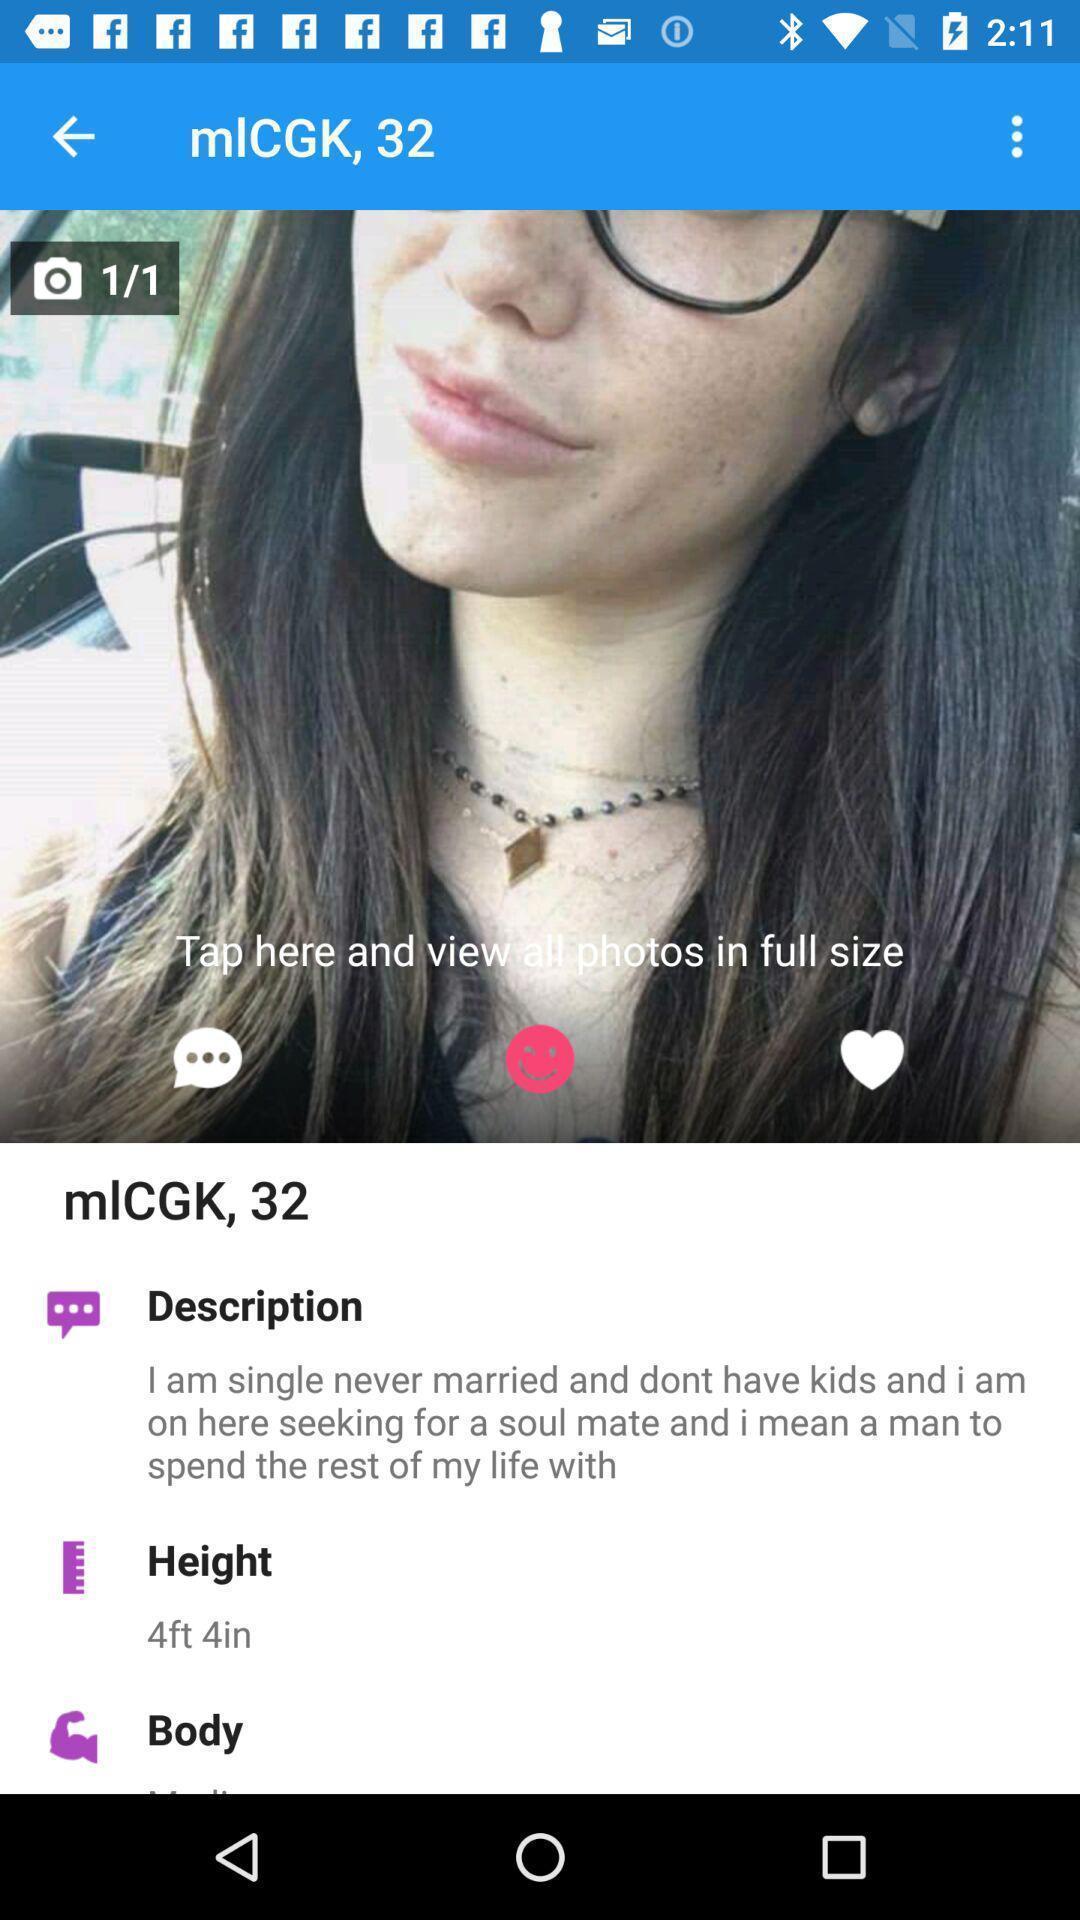Give me a summary of this screen capture. Screen displaying the profile details. 